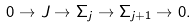<formula> <loc_0><loc_0><loc_500><loc_500>0 \to J \to \Sigma _ { j } \to \Sigma _ { j + 1 } \to 0 .</formula> 